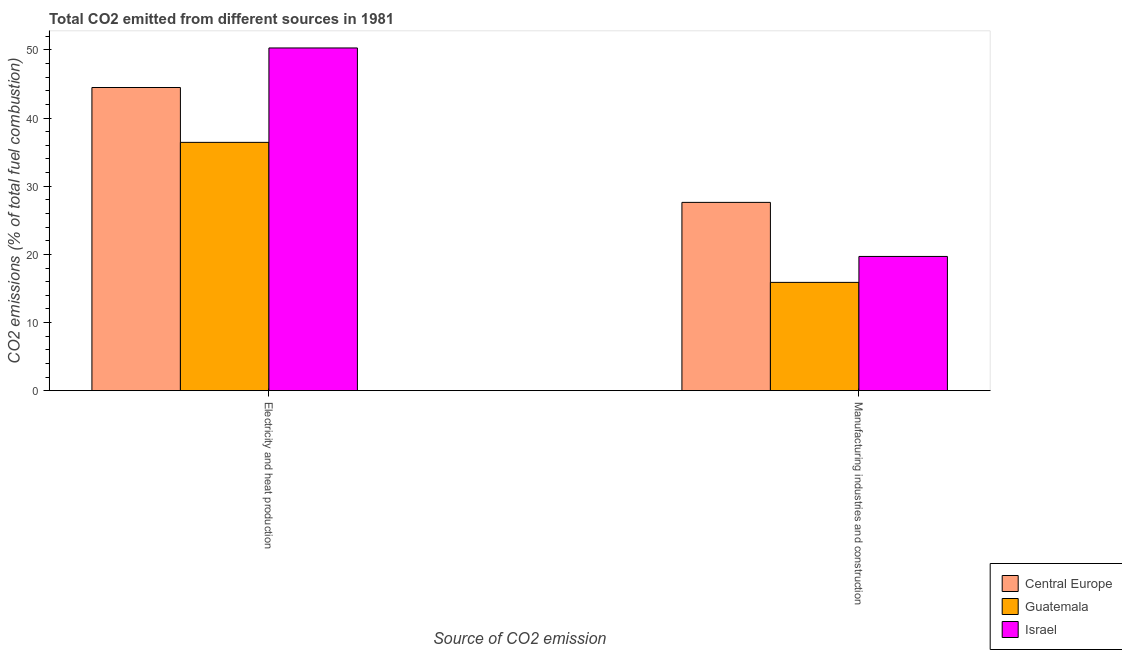How many groups of bars are there?
Offer a very short reply. 2. Are the number of bars on each tick of the X-axis equal?
Keep it short and to the point. Yes. How many bars are there on the 2nd tick from the left?
Give a very brief answer. 3. What is the label of the 2nd group of bars from the left?
Ensure brevity in your answer.  Manufacturing industries and construction. What is the co2 emissions due to manufacturing industries in Central Europe?
Keep it short and to the point. 27.63. Across all countries, what is the maximum co2 emissions due to manufacturing industries?
Offer a terse response. 27.63. Across all countries, what is the minimum co2 emissions due to electricity and heat production?
Your answer should be compact. 36.44. In which country was the co2 emissions due to manufacturing industries minimum?
Offer a very short reply. Guatemala. What is the total co2 emissions due to electricity and heat production in the graph?
Your response must be concise. 131.22. What is the difference between the co2 emissions due to electricity and heat production in Guatemala and that in Central Europe?
Provide a succinct answer. -8.05. What is the difference between the co2 emissions due to electricity and heat production in Israel and the co2 emissions due to manufacturing industries in Guatemala?
Give a very brief answer. 34.4. What is the average co2 emissions due to electricity and heat production per country?
Provide a succinct answer. 43.74. What is the difference between the co2 emissions due to electricity and heat production and co2 emissions due to manufacturing industries in Israel?
Make the answer very short. 30.6. In how many countries, is the co2 emissions due to manufacturing industries greater than 36 %?
Offer a terse response. 0. What is the ratio of the co2 emissions due to manufacturing industries in Central Europe to that in Israel?
Provide a succinct answer. 1.4. Is the co2 emissions due to electricity and heat production in Guatemala less than that in Central Europe?
Offer a terse response. Yes. What does the 1st bar from the left in Manufacturing industries and construction represents?
Your answer should be very brief. Central Europe. What does the 2nd bar from the right in Electricity and heat production represents?
Give a very brief answer. Guatemala. How many bars are there?
Your answer should be compact. 6. Are all the bars in the graph horizontal?
Offer a very short reply. No. How many countries are there in the graph?
Your answer should be very brief. 3. What is the difference between two consecutive major ticks on the Y-axis?
Ensure brevity in your answer.  10. Are the values on the major ticks of Y-axis written in scientific E-notation?
Your response must be concise. No. Does the graph contain grids?
Ensure brevity in your answer.  No. Where does the legend appear in the graph?
Your answer should be very brief. Bottom right. What is the title of the graph?
Your response must be concise. Total CO2 emitted from different sources in 1981. What is the label or title of the X-axis?
Keep it short and to the point. Source of CO2 emission. What is the label or title of the Y-axis?
Provide a short and direct response. CO2 emissions (% of total fuel combustion). What is the CO2 emissions (% of total fuel combustion) in Central Europe in Electricity and heat production?
Offer a terse response. 44.49. What is the CO2 emissions (% of total fuel combustion) of Guatemala in Electricity and heat production?
Give a very brief answer. 36.44. What is the CO2 emissions (% of total fuel combustion) of Israel in Electricity and heat production?
Give a very brief answer. 50.29. What is the CO2 emissions (% of total fuel combustion) in Central Europe in Manufacturing industries and construction?
Your answer should be compact. 27.63. What is the CO2 emissions (% of total fuel combustion) in Guatemala in Manufacturing industries and construction?
Offer a terse response. 15.89. What is the CO2 emissions (% of total fuel combustion) in Israel in Manufacturing industries and construction?
Give a very brief answer. 19.7. Across all Source of CO2 emission, what is the maximum CO2 emissions (% of total fuel combustion) in Central Europe?
Your answer should be very brief. 44.49. Across all Source of CO2 emission, what is the maximum CO2 emissions (% of total fuel combustion) of Guatemala?
Offer a terse response. 36.44. Across all Source of CO2 emission, what is the maximum CO2 emissions (% of total fuel combustion) in Israel?
Your answer should be compact. 50.29. Across all Source of CO2 emission, what is the minimum CO2 emissions (% of total fuel combustion) in Central Europe?
Your response must be concise. 27.63. Across all Source of CO2 emission, what is the minimum CO2 emissions (% of total fuel combustion) of Guatemala?
Provide a short and direct response. 15.89. Across all Source of CO2 emission, what is the minimum CO2 emissions (% of total fuel combustion) in Israel?
Your answer should be compact. 19.7. What is the total CO2 emissions (% of total fuel combustion) of Central Europe in the graph?
Your response must be concise. 72.12. What is the total CO2 emissions (% of total fuel combustion) of Guatemala in the graph?
Offer a very short reply. 52.33. What is the total CO2 emissions (% of total fuel combustion) in Israel in the graph?
Give a very brief answer. 69.99. What is the difference between the CO2 emissions (% of total fuel combustion) of Central Europe in Electricity and heat production and that in Manufacturing industries and construction?
Make the answer very short. 16.86. What is the difference between the CO2 emissions (% of total fuel combustion) in Guatemala in Electricity and heat production and that in Manufacturing industries and construction?
Keep it short and to the point. 20.55. What is the difference between the CO2 emissions (% of total fuel combustion) in Israel in Electricity and heat production and that in Manufacturing industries and construction?
Give a very brief answer. 30.6. What is the difference between the CO2 emissions (% of total fuel combustion) of Central Europe in Electricity and heat production and the CO2 emissions (% of total fuel combustion) of Guatemala in Manufacturing industries and construction?
Ensure brevity in your answer.  28.6. What is the difference between the CO2 emissions (% of total fuel combustion) of Central Europe in Electricity and heat production and the CO2 emissions (% of total fuel combustion) of Israel in Manufacturing industries and construction?
Make the answer very short. 24.8. What is the difference between the CO2 emissions (% of total fuel combustion) of Guatemala in Electricity and heat production and the CO2 emissions (% of total fuel combustion) of Israel in Manufacturing industries and construction?
Give a very brief answer. 16.74. What is the average CO2 emissions (% of total fuel combustion) of Central Europe per Source of CO2 emission?
Offer a very short reply. 36.06. What is the average CO2 emissions (% of total fuel combustion) in Guatemala per Source of CO2 emission?
Offer a terse response. 26.16. What is the average CO2 emissions (% of total fuel combustion) of Israel per Source of CO2 emission?
Provide a short and direct response. 35. What is the difference between the CO2 emissions (% of total fuel combustion) of Central Europe and CO2 emissions (% of total fuel combustion) of Guatemala in Electricity and heat production?
Keep it short and to the point. 8.05. What is the difference between the CO2 emissions (% of total fuel combustion) of Central Europe and CO2 emissions (% of total fuel combustion) of Israel in Electricity and heat production?
Provide a succinct answer. -5.8. What is the difference between the CO2 emissions (% of total fuel combustion) of Guatemala and CO2 emissions (% of total fuel combustion) of Israel in Electricity and heat production?
Make the answer very short. -13.86. What is the difference between the CO2 emissions (% of total fuel combustion) of Central Europe and CO2 emissions (% of total fuel combustion) of Guatemala in Manufacturing industries and construction?
Provide a succinct answer. 11.74. What is the difference between the CO2 emissions (% of total fuel combustion) of Central Europe and CO2 emissions (% of total fuel combustion) of Israel in Manufacturing industries and construction?
Give a very brief answer. 7.94. What is the difference between the CO2 emissions (% of total fuel combustion) in Guatemala and CO2 emissions (% of total fuel combustion) in Israel in Manufacturing industries and construction?
Make the answer very short. -3.81. What is the ratio of the CO2 emissions (% of total fuel combustion) in Central Europe in Electricity and heat production to that in Manufacturing industries and construction?
Offer a very short reply. 1.61. What is the ratio of the CO2 emissions (% of total fuel combustion) of Guatemala in Electricity and heat production to that in Manufacturing industries and construction?
Provide a succinct answer. 2.29. What is the ratio of the CO2 emissions (% of total fuel combustion) of Israel in Electricity and heat production to that in Manufacturing industries and construction?
Provide a succinct answer. 2.55. What is the difference between the highest and the second highest CO2 emissions (% of total fuel combustion) of Central Europe?
Your answer should be compact. 16.86. What is the difference between the highest and the second highest CO2 emissions (% of total fuel combustion) in Guatemala?
Keep it short and to the point. 20.55. What is the difference between the highest and the second highest CO2 emissions (% of total fuel combustion) of Israel?
Offer a terse response. 30.6. What is the difference between the highest and the lowest CO2 emissions (% of total fuel combustion) of Central Europe?
Offer a terse response. 16.86. What is the difference between the highest and the lowest CO2 emissions (% of total fuel combustion) in Guatemala?
Offer a very short reply. 20.55. What is the difference between the highest and the lowest CO2 emissions (% of total fuel combustion) in Israel?
Make the answer very short. 30.6. 